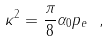Convert formula to latex. <formula><loc_0><loc_0><loc_500><loc_500>\kappa ^ { 2 } = \frac { \pi } { 8 } \alpha _ { 0 } p _ { e } \ ,</formula> 